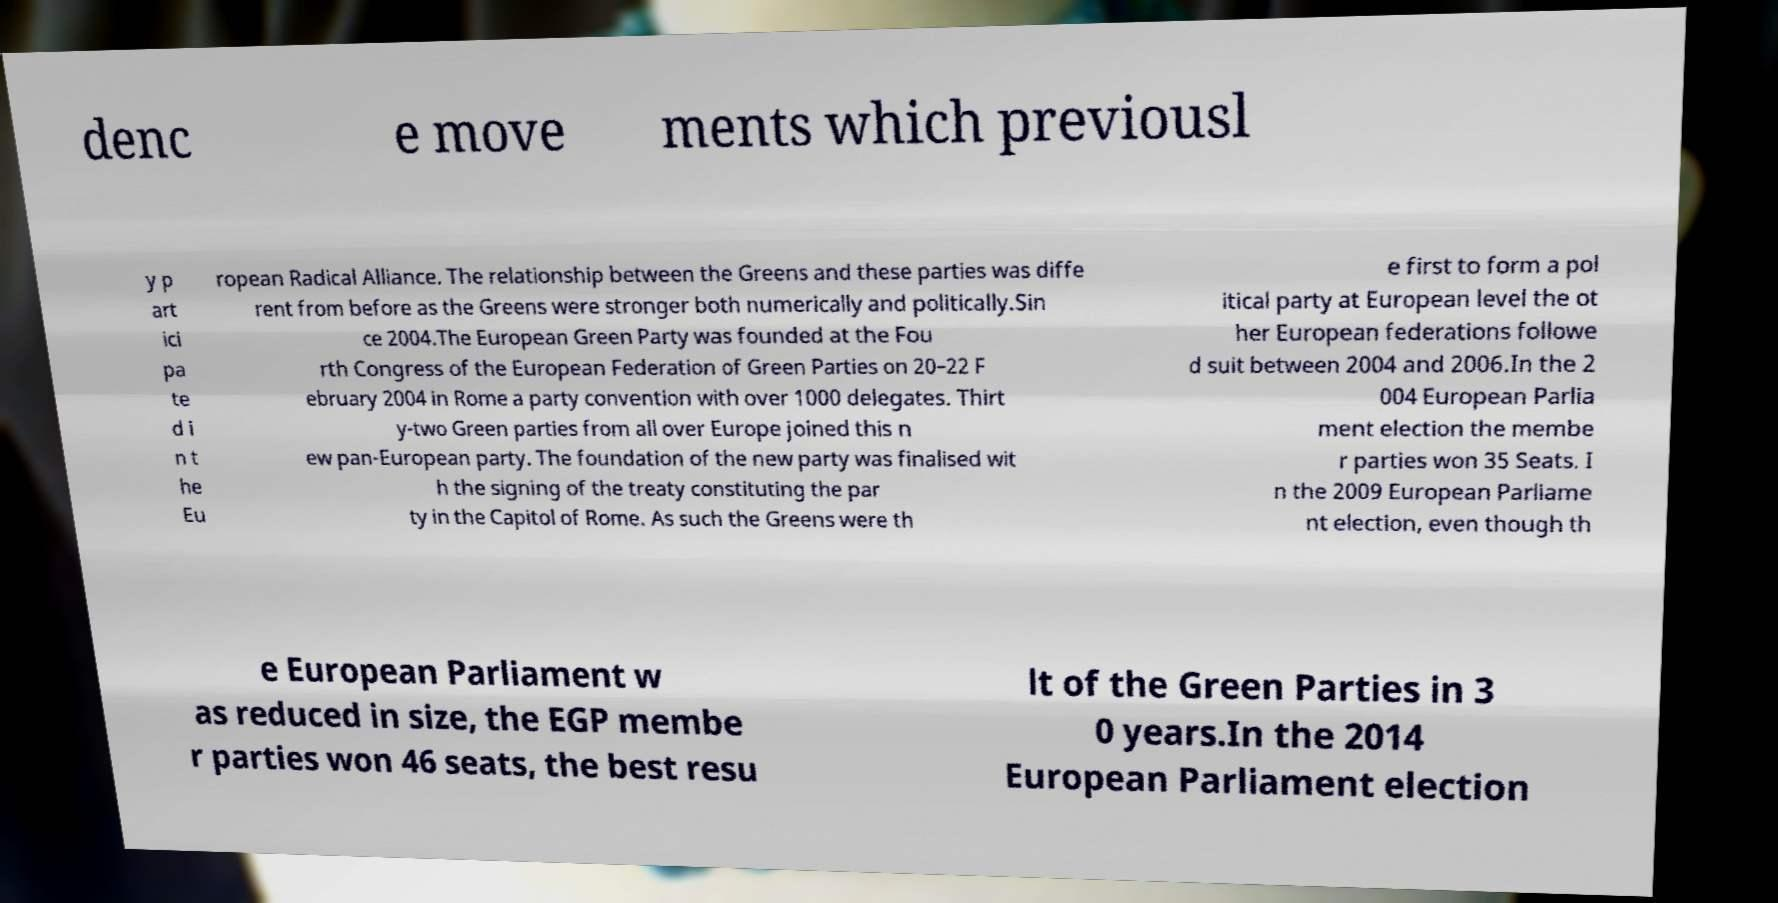There's text embedded in this image that I need extracted. Can you transcribe it verbatim? denc e move ments which previousl y p art ici pa te d i n t he Eu ropean Radical Alliance. The relationship between the Greens and these parties was diffe rent from before as the Greens were stronger both numerically and politically.Sin ce 2004.The European Green Party was founded at the Fou rth Congress of the European Federation of Green Parties on 20–22 F ebruary 2004 in Rome a party convention with over 1000 delegates. Thirt y-two Green parties from all over Europe joined this n ew pan-European party. The foundation of the new party was finalised wit h the signing of the treaty constituting the par ty in the Capitol of Rome. As such the Greens were th e first to form a pol itical party at European level the ot her European federations followe d suit between 2004 and 2006.In the 2 004 European Parlia ment election the membe r parties won 35 Seats. I n the 2009 European Parliame nt election, even though th e European Parliament w as reduced in size, the EGP membe r parties won 46 seats, the best resu lt of the Green Parties in 3 0 years.In the 2014 European Parliament election 